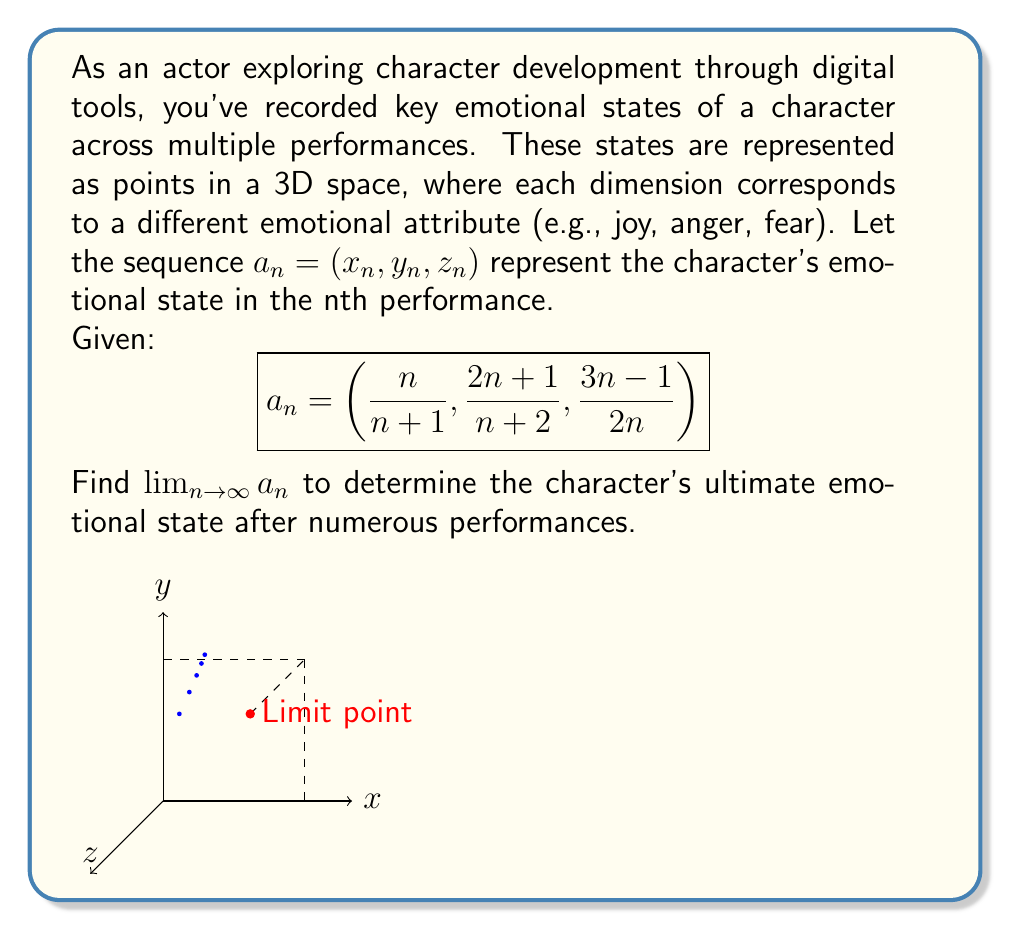Help me with this question. To find the limit of the sequence $a_n$ as $n$ approaches infinity, we need to evaluate the limit of each component separately:

1. For $x_n = \frac{n}{n+1}$:
   $$\lim_{n \to \infty} x_n = \lim_{n \to \infty} \frac{n}{n+1} = \lim_{n \to \infty} \frac{1}{1+\frac{1}{n}} = \frac{1}{1+0} = 1$$

2. For $y_n = \frac{2n+1}{n+2}$:
   $$\lim_{n \to \infty} y_n = \lim_{n \to \infty} \frac{2n+1}{n+2} = \lim_{n \to \infty} \frac{2+\frac{1}{n}}{1+\frac{2}{n}} = \frac{2+0}{1+0} = 1$$

3. For $z_n = \frac{3n-1}{2n}$:
   $$\lim_{n \to \infty} z_n = \lim_{n \to \infty} \frac{3n-1}{2n} = \lim_{n \to \infty} \frac{3-\frac{1}{n}}{2} = \frac{3-0}{2} = \frac{3}{2}$$

Therefore, the limit of the sequence $a_n$ is:

$$\lim_{n \to \infty} a_n = \left(\lim_{n \to \infty} x_n, \lim_{n \to \infty} y_n, \lim_{n \to \infty} z_n\right) = \left(1, 1, \frac{3}{2}\right)$$

This point represents the ultimate emotional state of the character after numerous performances.
Answer: $\left(1, 1, \frac{3}{2}\right)$ 